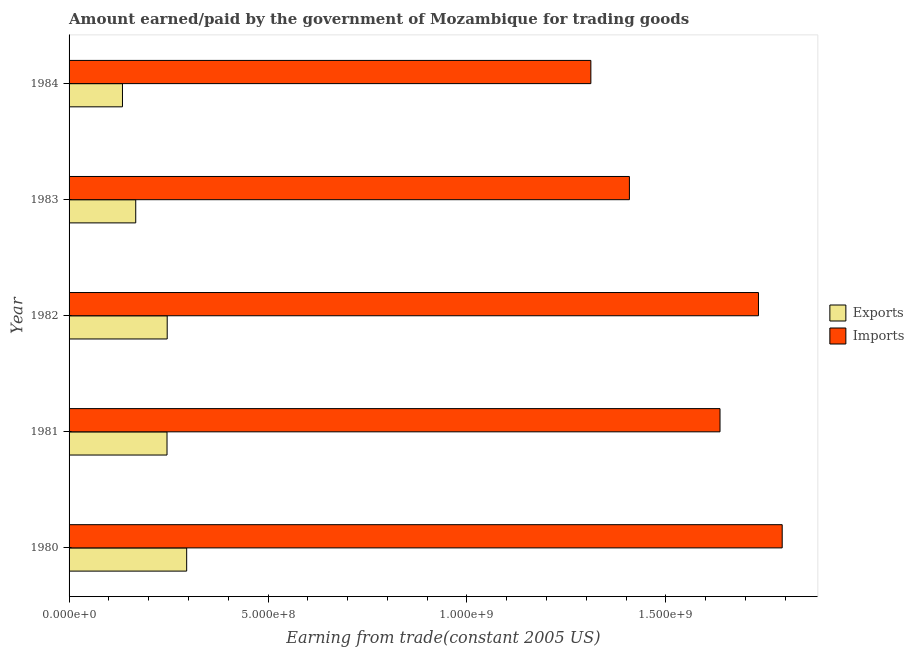How many different coloured bars are there?
Provide a short and direct response. 2. How many groups of bars are there?
Give a very brief answer. 5. Are the number of bars on each tick of the Y-axis equal?
Your answer should be very brief. Yes. How many bars are there on the 1st tick from the top?
Keep it short and to the point. 2. How many bars are there on the 5th tick from the bottom?
Make the answer very short. 2. What is the label of the 5th group of bars from the top?
Keep it short and to the point. 1980. In how many cases, is the number of bars for a given year not equal to the number of legend labels?
Ensure brevity in your answer.  0. What is the amount paid for imports in 1981?
Keep it short and to the point. 1.64e+09. Across all years, what is the maximum amount earned from exports?
Make the answer very short. 2.96e+08. Across all years, what is the minimum amount earned from exports?
Make the answer very short. 1.34e+08. In which year was the amount earned from exports maximum?
Offer a very short reply. 1980. In which year was the amount earned from exports minimum?
Provide a succinct answer. 1984. What is the total amount paid for imports in the graph?
Keep it short and to the point. 7.88e+09. What is the difference between the amount earned from exports in 1981 and that in 1982?
Keep it short and to the point. -4.71e+05. What is the difference between the amount paid for imports in 1981 and the amount earned from exports in 1984?
Make the answer very short. 1.50e+09. What is the average amount paid for imports per year?
Your answer should be very brief. 1.58e+09. In the year 1983, what is the difference between the amount paid for imports and amount earned from exports?
Your answer should be very brief. 1.24e+09. What is the ratio of the amount earned from exports in 1980 to that in 1983?
Provide a succinct answer. 1.76. Is the difference between the amount paid for imports in 1981 and 1984 greater than the difference between the amount earned from exports in 1981 and 1984?
Give a very brief answer. Yes. What is the difference between the highest and the second highest amount paid for imports?
Provide a short and direct response. 5.96e+07. What is the difference between the highest and the lowest amount earned from exports?
Offer a very short reply. 1.61e+08. In how many years, is the amount earned from exports greater than the average amount earned from exports taken over all years?
Keep it short and to the point. 3. Is the sum of the amount earned from exports in 1982 and 1984 greater than the maximum amount paid for imports across all years?
Your response must be concise. No. What does the 1st bar from the top in 1983 represents?
Your response must be concise. Imports. What does the 2nd bar from the bottom in 1980 represents?
Keep it short and to the point. Imports. How many years are there in the graph?
Your response must be concise. 5. What is the difference between two consecutive major ticks on the X-axis?
Provide a short and direct response. 5.00e+08. Does the graph contain grids?
Your response must be concise. No. Where does the legend appear in the graph?
Your response must be concise. Center right. How are the legend labels stacked?
Ensure brevity in your answer.  Vertical. What is the title of the graph?
Offer a very short reply. Amount earned/paid by the government of Mozambique for trading goods. Does "Fixed telephone" appear as one of the legend labels in the graph?
Offer a very short reply. No. What is the label or title of the X-axis?
Make the answer very short. Earning from trade(constant 2005 US). What is the Earning from trade(constant 2005 US) in Exports in 1980?
Keep it short and to the point. 2.96e+08. What is the Earning from trade(constant 2005 US) of Imports in 1980?
Your response must be concise. 1.79e+09. What is the Earning from trade(constant 2005 US) in Exports in 1981?
Your answer should be compact. 2.46e+08. What is the Earning from trade(constant 2005 US) in Imports in 1981?
Provide a short and direct response. 1.64e+09. What is the Earning from trade(constant 2005 US) in Exports in 1982?
Your answer should be compact. 2.47e+08. What is the Earning from trade(constant 2005 US) of Imports in 1982?
Your response must be concise. 1.73e+09. What is the Earning from trade(constant 2005 US) in Exports in 1983?
Ensure brevity in your answer.  1.68e+08. What is the Earning from trade(constant 2005 US) of Imports in 1983?
Make the answer very short. 1.41e+09. What is the Earning from trade(constant 2005 US) in Exports in 1984?
Keep it short and to the point. 1.34e+08. What is the Earning from trade(constant 2005 US) of Imports in 1984?
Offer a terse response. 1.31e+09. Across all years, what is the maximum Earning from trade(constant 2005 US) in Exports?
Ensure brevity in your answer.  2.96e+08. Across all years, what is the maximum Earning from trade(constant 2005 US) of Imports?
Ensure brevity in your answer.  1.79e+09. Across all years, what is the minimum Earning from trade(constant 2005 US) of Exports?
Make the answer very short. 1.34e+08. Across all years, what is the minimum Earning from trade(constant 2005 US) of Imports?
Ensure brevity in your answer.  1.31e+09. What is the total Earning from trade(constant 2005 US) of Exports in the graph?
Your answer should be compact. 1.09e+09. What is the total Earning from trade(constant 2005 US) of Imports in the graph?
Ensure brevity in your answer.  7.88e+09. What is the difference between the Earning from trade(constant 2005 US) in Exports in 1980 and that in 1981?
Offer a terse response. 4.94e+07. What is the difference between the Earning from trade(constant 2005 US) of Imports in 1980 and that in 1981?
Make the answer very short. 1.56e+08. What is the difference between the Earning from trade(constant 2005 US) in Exports in 1980 and that in 1982?
Offer a terse response. 4.89e+07. What is the difference between the Earning from trade(constant 2005 US) of Imports in 1980 and that in 1982?
Give a very brief answer. 5.96e+07. What is the difference between the Earning from trade(constant 2005 US) in Exports in 1980 and that in 1983?
Your response must be concise. 1.28e+08. What is the difference between the Earning from trade(constant 2005 US) in Imports in 1980 and that in 1983?
Your answer should be very brief. 3.84e+08. What is the difference between the Earning from trade(constant 2005 US) in Exports in 1980 and that in 1984?
Offer a very short reply. 1.61e+08. What is the difference between the Earning from trade(constant 2005 US) in Imports in 1980 and that in 1984?
Make the answer very short. 4.81e+08. What is the difference between the Earning from trade(constant 2005 US) of Exports in 1981 and that in 1982?
Give a very brief answer. -4.71e+05. What is the difference between the Earning from trade(constant 2005 US) in Imports in 1981 and that in 1982?
Ensure brevity in your answer.  -9.66e+07. What is the difference between the Earning from trade(constant 2005 US) of Exports in 1981 and that in 1983?
Ensure brevity in your answer.  7.86e+07. What is the difference between the Earning from trade(constant 2005 US) in Imports in 1981 and that in 1983?
Your answer should be very brief. 2.28e+08. What is the difference between the Earning from trade(constant 2005 US) of Exports in 1981 and that in 1984?
Ensure brevity in your answer.  1.12e+08. What is the difference between the Earning from trade(constant 2005 US) of Imports in 1981 and that in 1984?
Provide a succinct answer. 3.25e+08. What is the difference between the Earning from trade(constant 2005 US) of Exports in 1982 and that in 1983?
Offer a very short reply. 7.91e+07. What is the difference between the Earning from trade(constant 2005 US) of Imports in 1982 and that in 1983?
Keep it short and to the point. 3.24e+08. What is the difference between the Earning from trade(constant 2005 US) of Exports in 1982 and that in 1984?
Offer a terse response. 1.12e+08. What is the difference between the Earning from trade(constant 2005 US) of Imports in 1982 and that in 1984?
Ensure brevity in your answer.  4.21e+08. What is the difference between the Earning from trade(constant 2005 US) in Exports in 1983 and that in 1984?
Provide a short and direct response. 3.33e+07. What is the difference between the Earning from trade(constant 2005 US) in Imports in 1983 and that in 1984?
Offer a very short reply. 9.69e+07. What is the difference between the Earning from trade(constant 2005 US) of Exports in 1980 and the Earning from trade(constant 2005 US) of Imports in 1981?
Provide a succinct answer. -1.34e+09. What is the difference between the Earning from trade(constant 2005 US) of Exports in 1980 and the Earning from trade(constant 2005 US) of Imports in 1982?
Offer a very short reply. -1.44e+09. What is the difference between the Earning from trade(constant 2005 US) of Exports in 1980 and the Earning from trade(constant 2005 US) of Imports in 1983?
Offer a very short reply. -1.11e+09. What is the difference between the Earning from trade(constant 2005 US) of Exports in 1980 and the Earning from trade(constant 2005 US) of Imports in 1984?
Your answer should be compact. -1.02e+09. What is the difference between the Earning from trade(constant 2005 US) of Exports in 1981 and the Earning from trade(constant 2005 US) of Imports in 1982?
Ensure brevity in your answer.  -1.49e+09. What is the difference between the Earning from trade(constant 2005 US) of Exports in 1981 and the Earning from trade(constant 2005 US) of Imports in 1983?
Offer a terse response. -1.16e+09. What is the difference between the Earning from trade(constant 2005 US) of Exports in 1981 and the Earning from trade(constant 2005 US) of Imports in 1984?
Provide a succinct answer. -1.07e+09. What is the difference between the Earning from trade(constant 2005 US) of Exports in 1982 and the Earning from trade(constant 2005 US) of Imports in 1983?
Provide a succinct answer. -1.16e+09. What is the difference between the Earning from trade(constant 2005 US) of Exports in 1982 and the Earning from trade(constant 2005 US) of Imports in 1984?
Offer a terse response. -1.06e+09. What is the difference between the Earning from trade(constant 2005 US) in Exports in 1983 and the Earning from trade(constant 2005 US) in Imports in 1984?
Make the answer very short. -1.14e+09. What is the average Earning from trade(constant 2005 US) of Exports per year?
Ensure brevity in your answer.  2.18e+08. What is the average Earning from trade(constant 2005 US) in Imports per year?
Your answer should be compact. 1.58e+09. In the year 1980, what is the difference between the Earning from trade(constant 2005 US) of Exports and Earning from trade(constant 2005 US) of Imports?
Ensure brevity in your answer.  -1.50e+09. In the year 1981, what is the difference between the Earning from trade(constant 2005 US) of Exports and Earning from trade(constant 2005 US) of Imports?
Offer a terse response. -1.39e+09. In the year 1982, what is the difference between the Earning from trade(constant 2005 US) of Exports and Earning from trade(constant 2005 US) of Imports?
Offer a very short reply. -1.49e+09. In the year 1983, what is the difference between the Earning from trade(constant 2005 US) in Exports and Earning from trade(constant 2005 US) in Imports?
Make the answer very short. -1.24e+09. In the year 1984, what is the difference between the Earning from trade(constant 2005 US) in Exports and Earning from trade(constant 2005 US) in Imports?
Provide a short and direct response. -1.18e+09. What is the ratio of the Earning from trade(constant 2005 US) in Exports in 1980 to that in 1981?
Ensure brevity in your answer.  1.2. What is the ratio of the Earning from trade(constant 2005 US) of Imports in 1980 to that in 1981?
Offer a terse response. 1.1. What is the ratio of the Earning from trade(constant 2005 US) of Exports in 1980 to that in 1982?
Offer a terse response. 1.2. What is the ratio of the Earning from trade(constant 2005 US) of Imports in 1980 to that in 1982?
Keep it short and to the point. 1.03. What is the ratio of the Earning from trade(constant 2005 US) in Exports in 1980 to that in 1983?
Your response must be concise. 1.76. What is the ratio of the Earning from trade(constant 2005 US) in Imports in 1980 to that in 1983?
Offer a very short reply. 1.27. What is the ratio of the Earning from trade(constant 2005 US) in Exports in 1980 to that in 1984?
Your answer should be very brief. 2.2. What is the ratio of the Earning from trade(constant 2005 US) of Imports in 1980 to that in 1984?
Give a very brief answer. 1.37. What is the ratio of the Earning from trade(constant 2005 US) in Imports in 1981 to that in 1982?
Offer a very short reply. 0.94. What is the ratio of the Earning from trade(constant 2005 US) of Exports in 1981 to that in 1983?
Provide a short and direct response. 1.47. What is the ratio of the Earning from trade(constant 2005 US) in Imports in 1981 to that in 1983?
Give a very brief answer. 1.16. What is the ratio of the Earning from trade(constant 2005 US) of Exports in 1981 to that in 1984?
Provide a succinct answer. 1.83. What is the ratio of the Earning from trade(constant 2005 US) of Imports in 1981 to that in 1984?
Offer a terse response. 1.25. What is the ratio of the Earning from trade(constant 2005 US) in Exports in 1982 to that in 1983?
Offer a terse response. 1.47. What is the ratio of the Earning from trade(constant 2005 US) in Imports in 1982 to that in 1983?
Make the answer very short. 1.23. What is the ratio of the Earning from trade(constant 2005 US) in Exports in 1982 to that in 1984?
Make the answer very short. 1.84. What is the ratio of the Earning from trade(constant 2005 US) of Imports in 1982 to that in 1984?
Provide a succinct answer. 1.32. What is the ratio of the Earning from trade(constant 2005 US) of Exports in 1983 to that in 1984?
Your answer should be very brief. 1.25. What is the ratio of the Earning from trade(constant 2005 US) in Imports in 1983 to that in 1984?
Provide a short and direct response. 1.07. What is the difference between the highest and the second highest Earning from trade(constant 2005 US) of Exports?
Give a very brief answer. 4.89e+07. What is the difference between the highest and the second highest Earning from trade(constant 2005 US) of Imports?
Offer a very short reply. 5.96e+07. What is the difference between the highest and the lowest Earning from trade(constant 2005 US) in Exports?
Your answer should be compact. 1.61e+08. What is the difference between the highest and the lowest Earning from trade(constant 2005 US) in Imports?
Make the answer very short. 4.81e+08. 